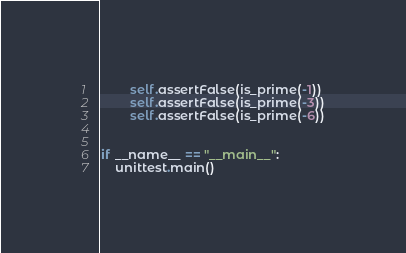<code> <loc_0><loc_0><loc_500><loc_500><_Python_>        self.assertFalse(is_prime(-1))
        self.assertFalse(is_prime(-3))
        self.assertFalse(is_prime(-6))


if __name__ == "__main__":
    unittest.main()
</code> 